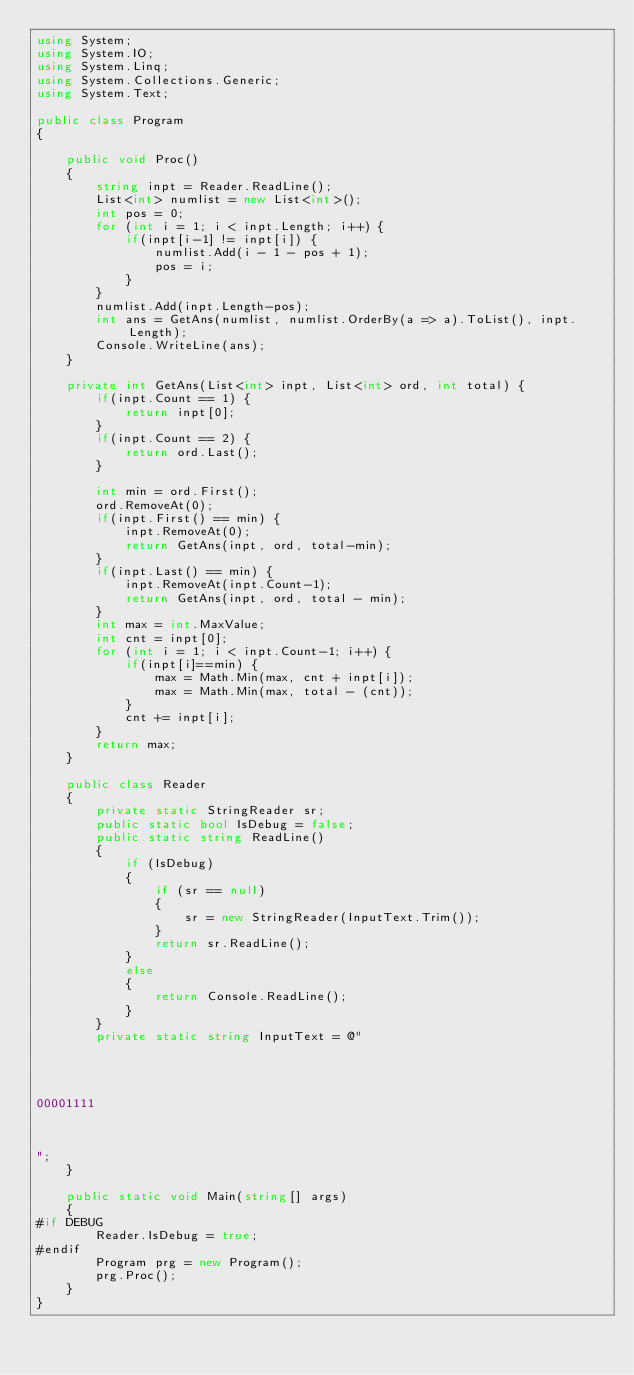<code> <loc_0><loc_0><loc_500><loc_500><_C#_>using System;
using System.IO;
using System.Linq;
using System.Collections.Generic;
using System.Text;

public class Program
{

    public void Proc()
    {
        string inpt = Reader.ReadLine();
        List<int> numlist = new List<int>();
        int pos = 0; 
        for (int i = 1; i < inpt.Length; i++) {
            if(inpt[i-1] != inpt[i]) {
                numlist.Add(i - 1 - pos + 1);
                pos = i;
            }
        }
        numlist.Add(inpt.Length-pos);
        int ans = GetAns(numlist, numlist.OrderBy(a => a).ToList(), inpt.Length);
        Console.WriteLine(ans);
    }

    private int GetAns(List<int> inpt, List<int> ord, int total) {
        if(inpt.Count == 1) {
            return inpt[0];
        }
        if(inpt.Count == 2) {
            return ord.Last();
        }

        int min = ord.First();
        ord.RemoveAt(0);
        if(inpt.First() == min) {
            inpt.RemoveAt(0);
            return GetAns(inpt, ord, total-min);
        }
        if(inpt.Last() == min) {
            inpt.RemoveAt(inpt.Count-1);
            return GetAns(inpt, ord, total - min);
        }
        int max = int.MaxValue;
        int cnt = inpt[0];
        for (int i = 1; i < inpt.Count-1; i++) {
            if(inpt[i]==min) {
                max = Math.Min(max, cnt + inpt[i]);
                max = Math.Min(max, total - (cnt));
            }
            cnt += inpt[i];
        }
        return max;
    }

    public class Reader
    {
        private static StringReader sr;
        public static bool IsDebug = false;
        public static string ReadLine()
        {
            if (IsDebug)
            {
                if (sr == null)
                {
                    sr = new StringReader(InputText.Trim());
                }
                return sr.ReadLine();
            }
            else
            {
                return Console.ReadLine();
            }
        }
        private static string InputText = @"




00001111



";
    }

    public static void Main(string[] args)
    {
#if DEBUG
        Reader.IsDebug = true;
#endif
        Program prg = new Program();
        prg.Proc();
    }
}
</code> 